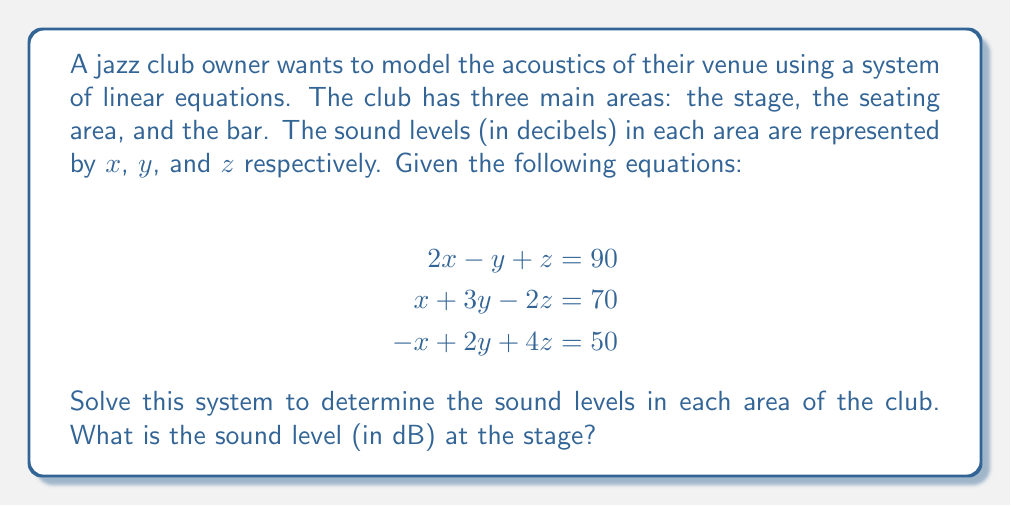Teach me how to tackle this problem. To solve this system of linear equations, we'll use the Gaussian elimination method:

1) First, write the augmented matrix:

   $$\begin{bmatrix}
   2 & -1 & 1 & 90 \\
   1 & 3 & -2 & 70 \\
   -1 & 2 & 4 & 50
   \end{bmatrix}$$

2) Multiply the first row by -1/2 and add it to the second row:

   $$\begin{bmatrix}
   2 & -1 & 1 & 90 \\
   0 & 3.5 & -2.5 & 25 \\
   -1 & 2 & 4 & 50
   \end{bmatrix}$$

3) Add the first row to the third row:

   $$\begin{bmatrix}
   2 & -1 & 1 & 90 \\
   0 & 3.5 & -2.5 & 25 \\
   0 & 1 & 5 & 140
   \end{bmatrix}$$

4) Multiply the second row by -2/7 and add it to the third row:

   $$\begin{bmatrix}
   2 & -1 & 1 & 90 \\
   0 & 3.5 & -2.5 & 25 \\
   0 & 0 & 5.714 & 135.714
   \end{bmatrix}$$

5) Now we have an upper triangular matrix. Solve for $z$:

   $5.714z = 135.714$
   $z = 23.75$

6) Substitute this value in the second equation:

   $3.5y - 2.5(23.75) = 25$
   $3.5y = 84.375$
   $y = 24.11$

7) Finally, substitute these values in the first equation:

   $2x - 24.11 + 23.75 = 90$
   $2x = 90.36$
   $x = 45.18$

Therefore, the sound level at the stage ($x$) is approximately 45.18 dB.
Answer: 45.18 dB 